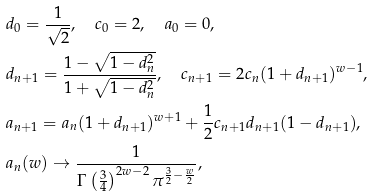<formula> <loc_0><loc_0><loc_500><loc_500>& d _ { 0 } = \frac { 1 } { \sqrt { 2 } } , \quad c _ { 0 } = 2 , \quad a _ { 0 } = 0 , \\ & d _ { n + 1 } = \frac { 1 - \sqrt { 1 - d _ { n } ^ { 2 } } } { 1 + \sqrt { 1 - d _ { n } ^ { 2 } } } , \quad c _ { n + 1 } = 2 c _ { n } ( 1 + d _ { n + 1 } ) ^ { w - 1 } , \\ & a _ { n + 1 } = a _ { n } ( 1 + d _ { n + 1 } ) ^ { w + 1 } + \frac { 1 } { 2 } c _ { n + 1 } d _ { n + 1 } ( 1 - d _ { n + 1 } ) , \\ & a _ { n } ( w ) \to \frac { 1 } { \Gamma \left ( \frac { 3 } { 4 } \right ) ^ { 2 w - 2 } { \pi ^ { \frac { 3 } { 2 } - \frac { w } { 2 } } } } ,</formula> 